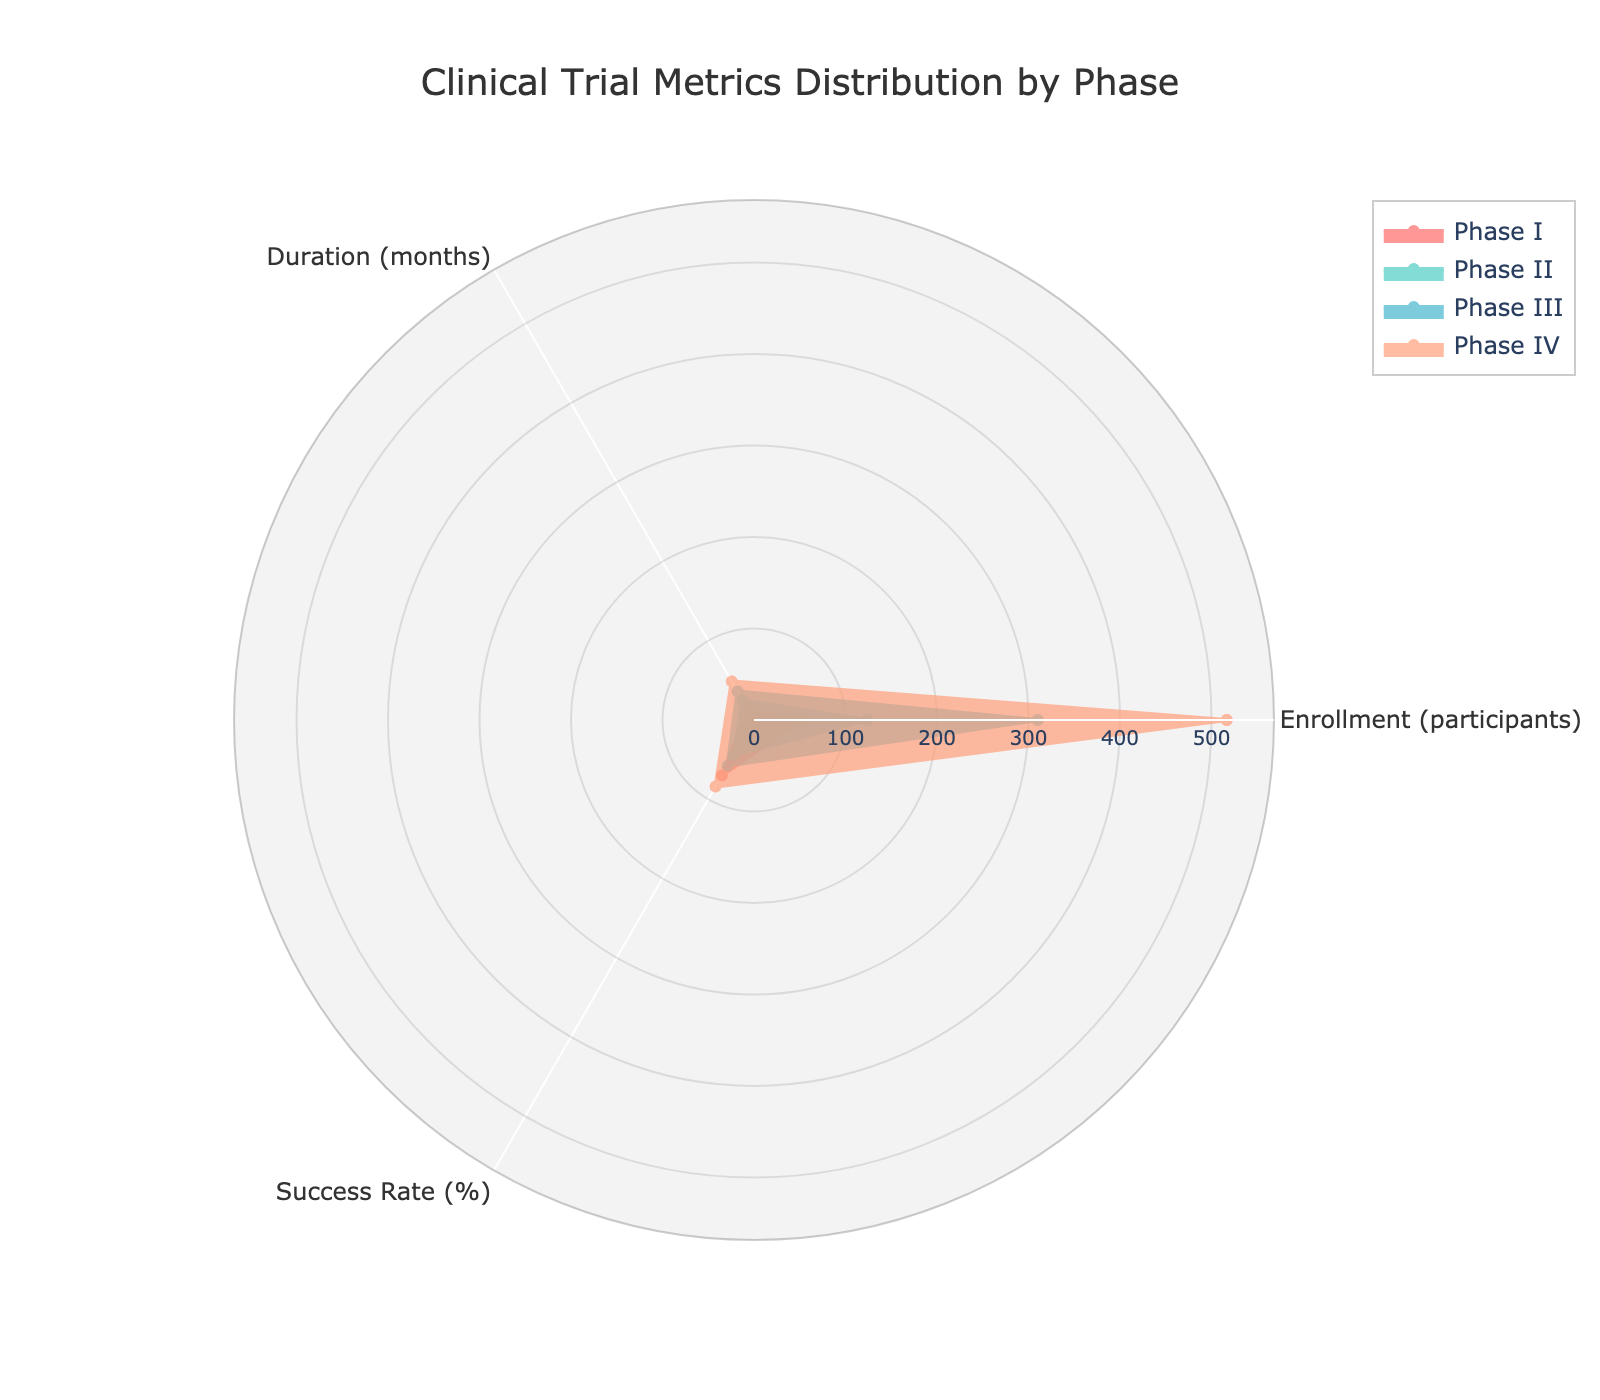What is the title of the radar chart? The title of the radar chart is usually located at the top of the figure. In this case, it is clearly stated at the top.
Answer: Clinical Trial Metrics Distribution by Phase Which phase has the highest average enrollment? To find the phase with the highest average enrollment, look for the phase with the largest radius value in the 'Enrollment (participants)' axis.
Answer: Phase IV What is the average duration for Phase II? The average duration for Phase II can be found by referring to the 'Duration (months)' axis and locating the value corresponding to Phase II.
Answer: 24.67 months By how much does the average success rate of Phase III differ from that of Phase I? Subtract the average success rate of Phase I from that of Phase III. Phase I has average success rates of approximately 70%, and Phase III has approximately 57.67%.
Answer: 12.33% Which phase shows the most balanced distribution among the three metrics? The most balanced distribution can be identified by looking for the phase whose polygon appears more regular and less skewed among the given metrics.
Answer: Phase I or Phase IV (more visually regular) Between Phases III and IV, which has a higher average success rate and by how much? Compare the success rates of Phase III and Phase IV. Phase III has about 57.67%, and Phase IV has about 84%. Subtract the former from the latter.
Answer: Phase IV by 26.33% In which phase is the difference between enrollment and duration the most pronounced? Calculate the difference between enrollment and duration for each phase, and identify the phase with the largest difference. For example, Phase IV shows a substantial difference.
Answer: Phase IV What is the average enrollment across all phases? Sum the average enrollments for all phases and divide by the number of phases. (50+60+45)/3 for Phase I, (100+150+120)/3 for Phase II, (300+350+280)/3 for Phase III, (500+600+450)/3 for Phase IV. Then average these values.
Answer: Approximately 250 participants How does the average duration of Phase I compare to the average duration of Phase IV? Compare the average values along the 'Duration (months)' axis for Phase I and Phase IV. Phase I has 12.33 months, and Phase IV has around 48.67 months.
Answer: Phase I is 36.34 months shorter than Phase IV 